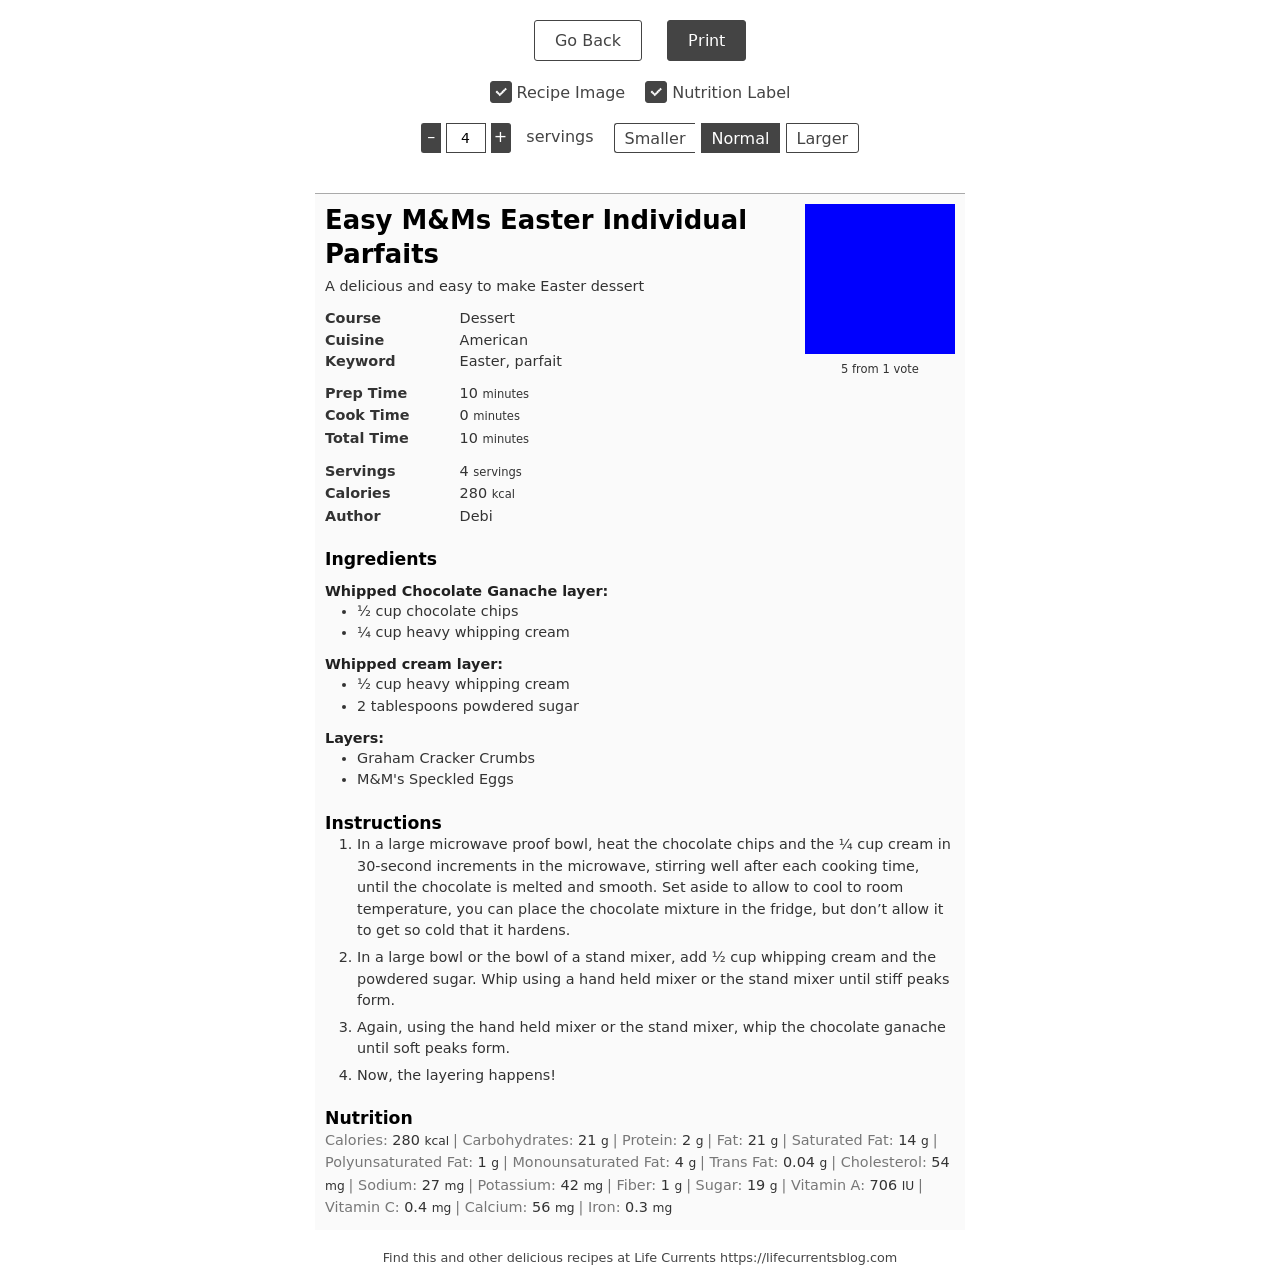Could you guide me through the process of developing this website with HTML? Certainly! To create a website like the one shown in the image, which displays information about an Easter-themed dessert recipe, you'd start by defining the HTML structure. Begin with a DOCTYPE declaration followed by the HTML tag. Inside, create a HEAD section for metadata and link stylesheets, and a BODY section where your content will live. For the recipe, you can use various HTML elements like divs for layout, h1 or h2 for headings, p for paragraphs, and img tags for images. Additionally, use ul or ol for any lists such as ingredients or instructions. Don't forget to implement a responsive layout with CSS to ensure your website looks good on both desktops and mobile devices. 